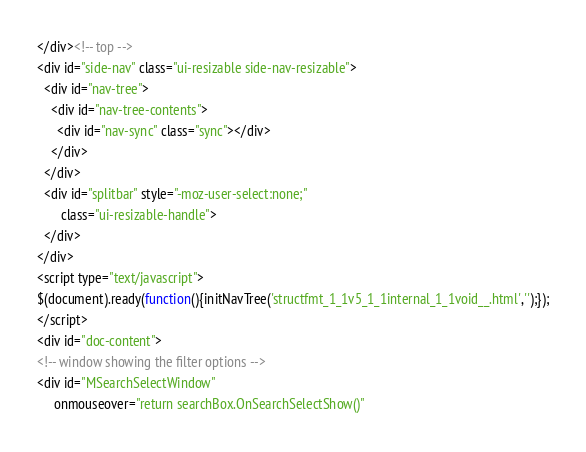<code> <loc_0><loc_0><loc_500><loc_500><_HTML_></div><!-- top -->
<div id="side-nav" class="ui-resizable side-nav-resizable">
  <div id="nav-tree">
    <div id="nav-tree-contents">
      <div id="nav-sync" class="sync"></div>
    </div>
  </div>
  <div id="splitbar" style="-moz-user-select:none;" 
       class="ui-resizable-handle">
  </div>
</div>
<script type="text/javascript">
$(document).ready(function(){initNavTree('structfmt_1_1v5_1_1internal_1_1void__.html','');});
</script>
<div id="doc-content">
<!-- window showing the filter options -->
<div id="MSearchSelectWindow"
     onmouseover="return searchBox.OnSearchSelectShow()"</code> 